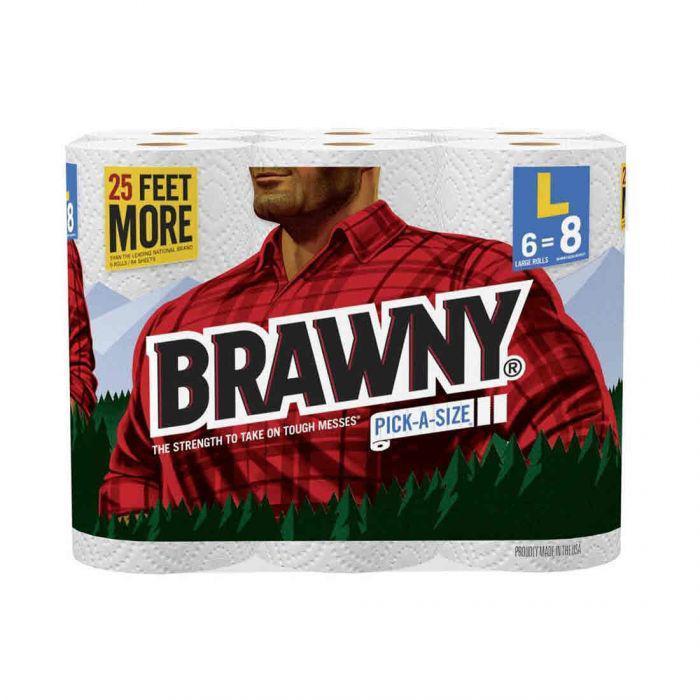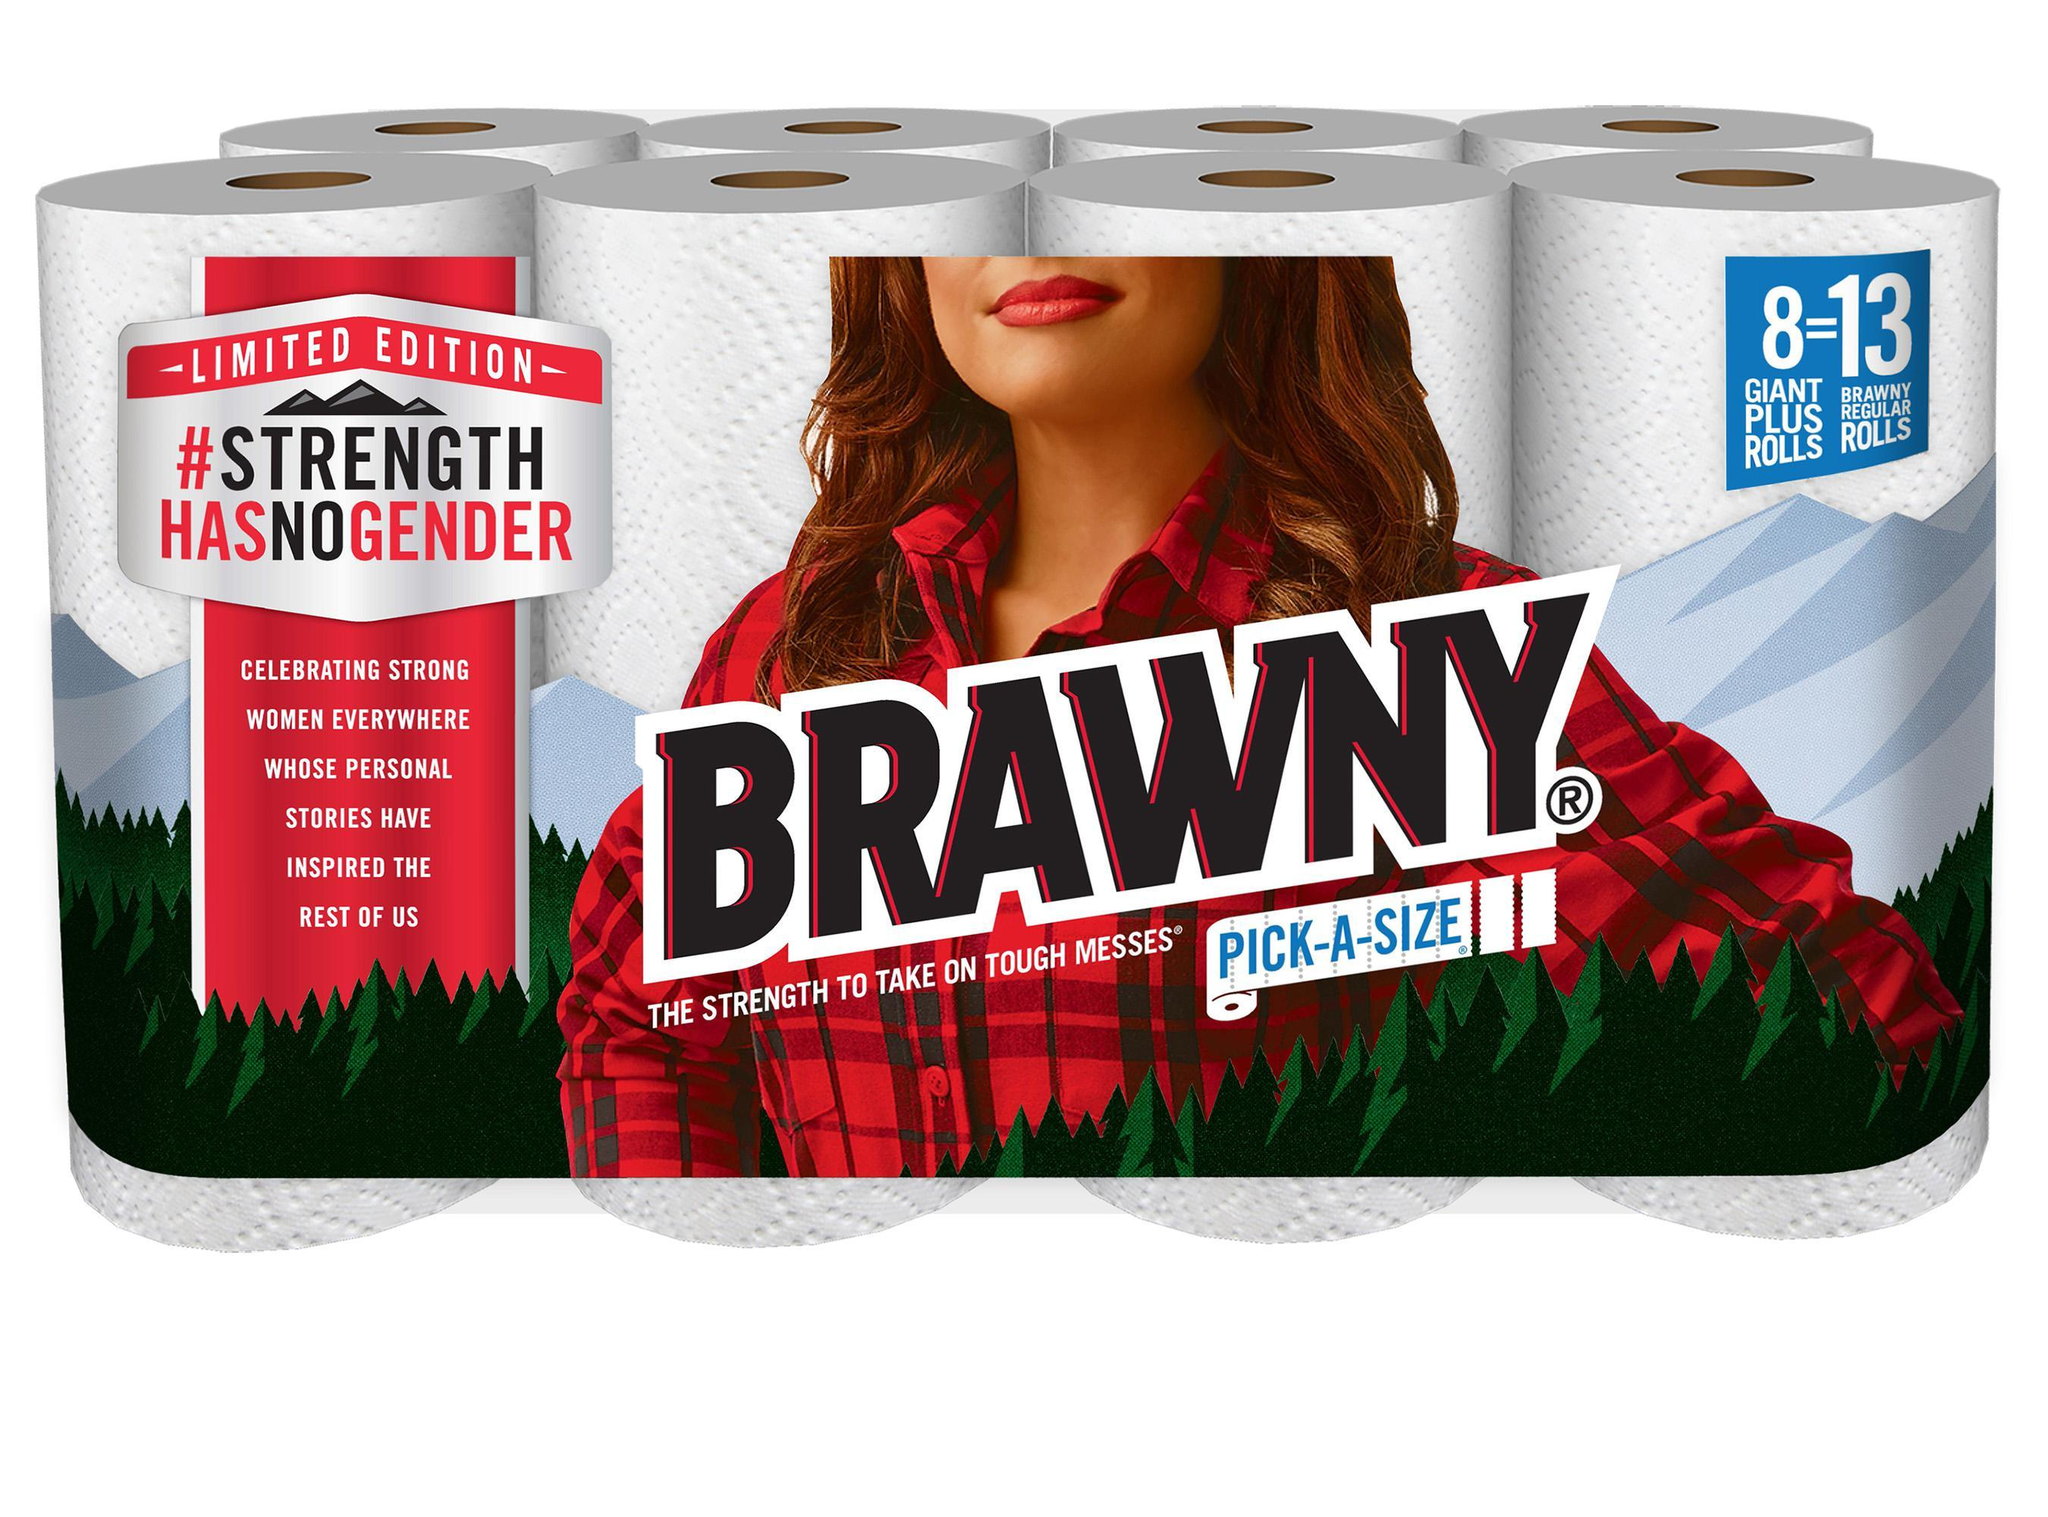The first image is the image on the left, the second image is the image on the right. Evaluate the accuracy of this statement regarding the images: "At least one image contains a single upright paper towel roll in a wrapper that features a red plaid shirt.". Is it true? Answer yes or no. No. The first image is the image on the left, the second image is the image on the right. Given the left and right images, does the statement "There are at least six rolls of paper towels in the package on the left." hold true? Answer yes or no. Yes. 